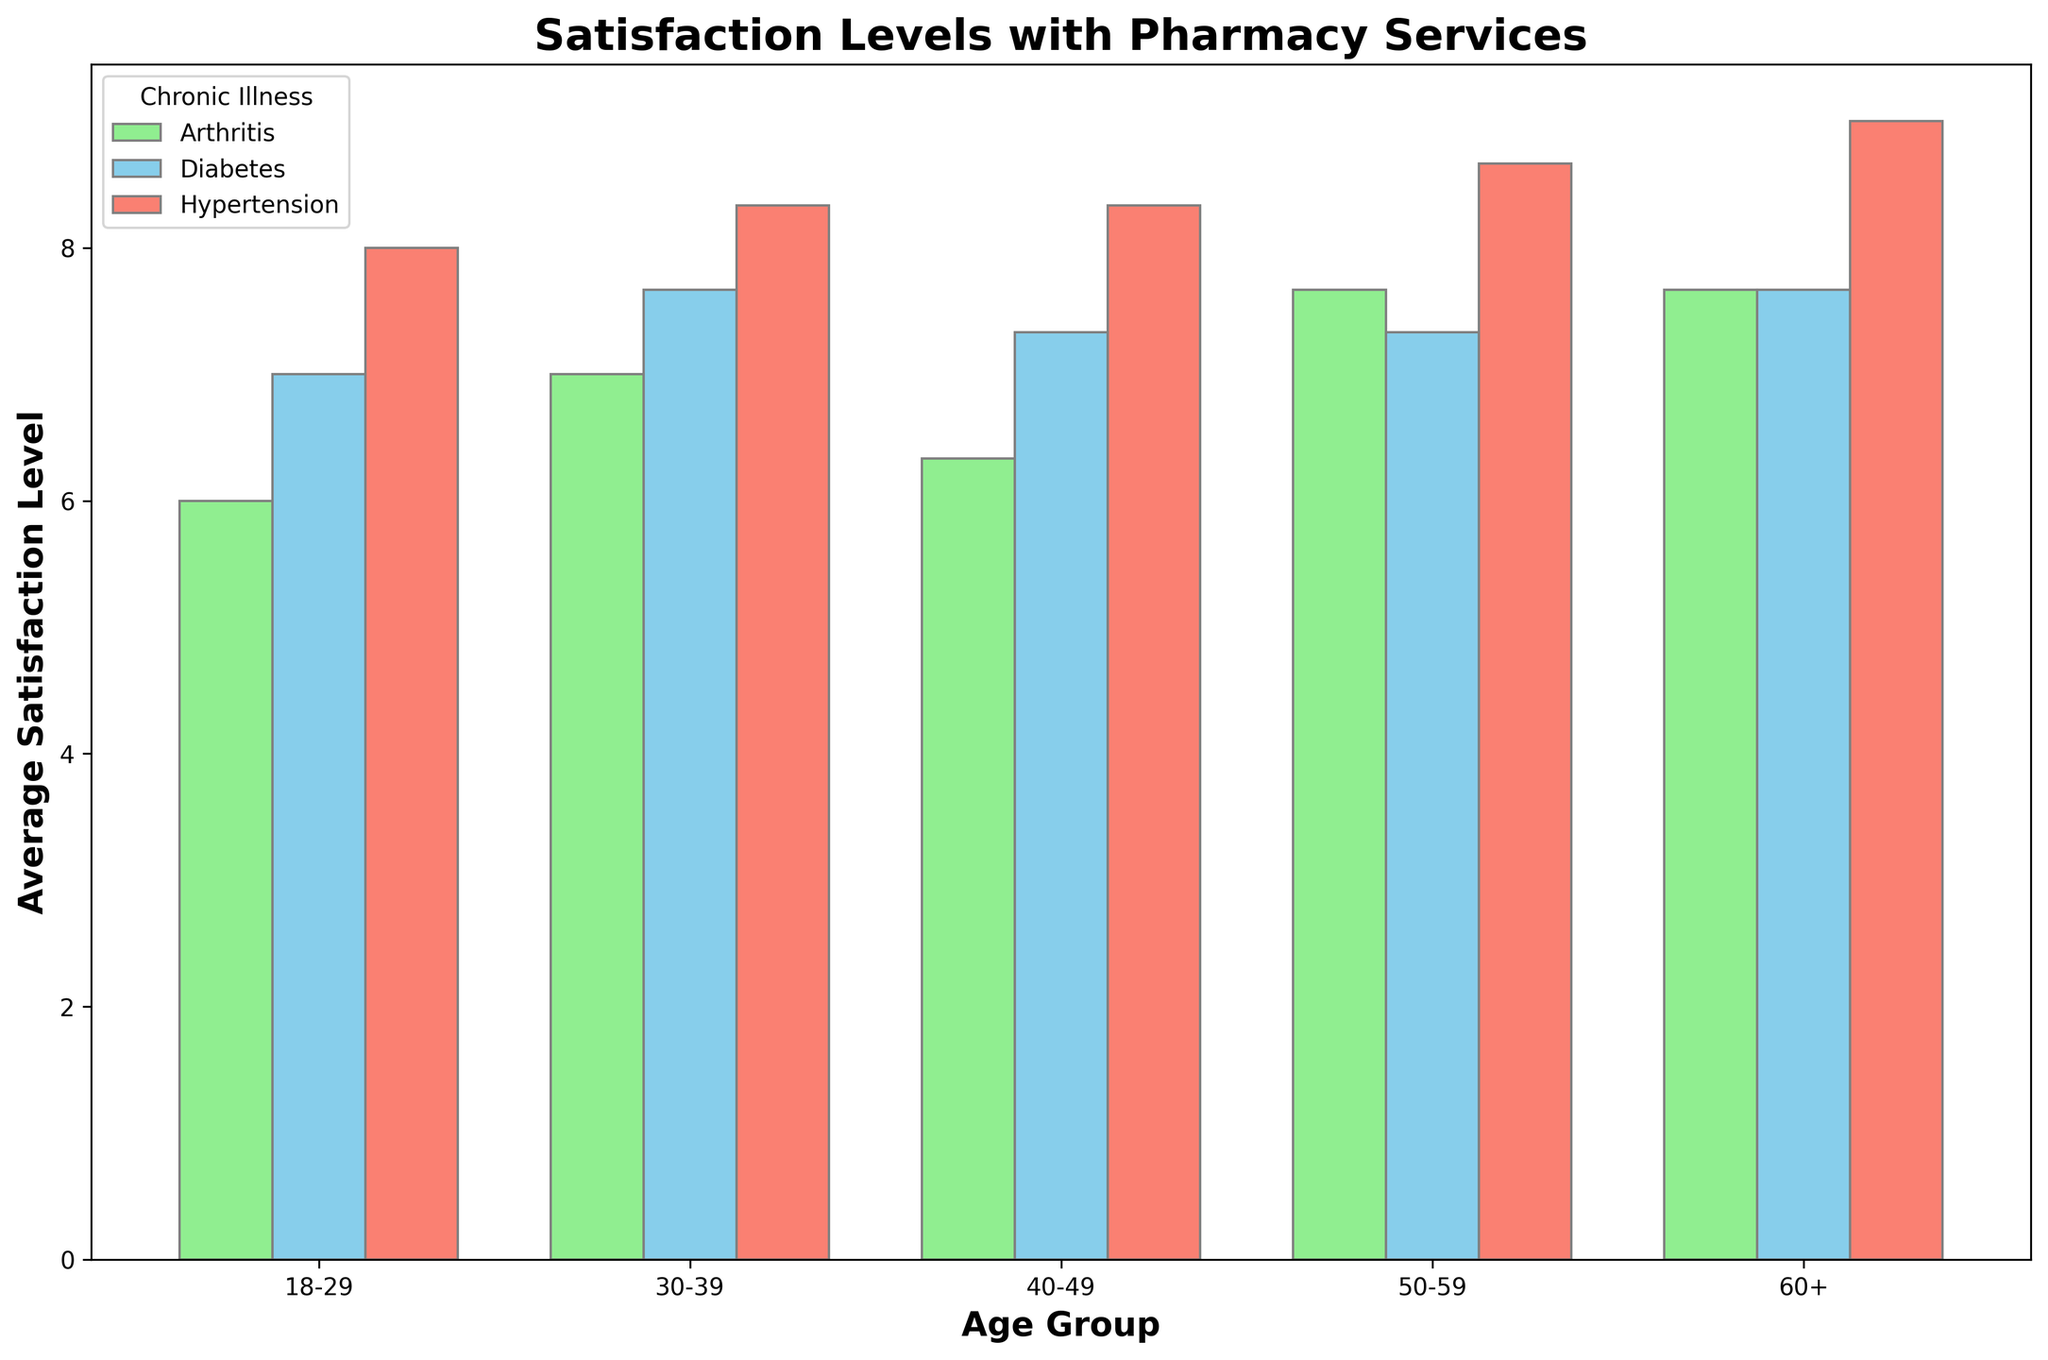What is the average satisfaction level for arthritis patients aged 30-39? Identify bars for arthritis patients within the 30-39 age group. The average satisfaction level is roughly 7 as seen from the bar height.
Answer: 7 Which illness has the highest average satisfaction level in the 60+ age group? Look at the colors representing illnesses within the 60+ age group. The highest bar in this group is for hypertension.
Answer: Hypertension Compare the average satisfaction levels between diabetes patients in the 18-29 and 40-49 age groups. Which is higher? Identify the bars for diabetes in the 18-29 and 40-49 age groups and compare their heights. The average satisfaction level is higher for the 40-49 age group.
Answer: 40-49 What is the difference in average satisfaction levels between hypertension patients in the 18-29 and 50-59 age groups? Identify bars representing hypertension in the 18-29 and 50-59 age groups. Subtract the average satisfaction level of 18-29 (around 8) from that of 50-59 (around 8.67). The difference is about 0.67.
Answer: 0.67 Among all age groups, which illness consistently shows the highest satisfaction levels? Observe the colors representing illnesses across all age groups. The red bars (hypertension) are consistently high across the plot.
Answer: Hypertension Which age group displays the greatest variation in satisfaction levels among patients with different illnesses? Compare the height differences of bars within each age group across illnesses. The 18-29 age group shows considerable variation among illnesses.
Answer: 18-29 Are the average satisfaction levels for diabetes patients higher in the age group 30-39 or 50-59? Identify bars for diabetes in the 30-39 and 50-59 age groups and compare their heights. The average satisfaction levels appear similar, both being about 7 or 8.
Answer: Similar What is the average satisfaction level for hypertension patients across all age groups? To compute the average, sum the heights of the bars representing hypertension for each age group and divide by the number of age groups (5). The average satisfaction level is approximately 8.6.
Answer: 8.6 Which age group has the lowest satisfaction levels for arthritis patients? Compare the heights of green bars (arthritis) across different age groups. The lowest average satisfaction level is in the 40-49 age group.
Answer: 40-49 Based on the figure, which disease and age group combination reports an average satisfaction level of around 9? Look for bars with a height around 9. Hypertension in the 18-29, 50-59, and 60+ age groups all report an average satisfaction level around 9.
Answer: Hypertension in 18-29, 50-59, 60+ 